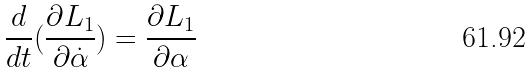<formula> <loc_0><loc_0><loc_500><loc_500>\frac { d } { d t } ( \frac { \partial L _ { 1 } } { \partial \dot { \alpha } } ) = \frac { \partial L _ { 1 } } { \partial \alpha }</formula> 